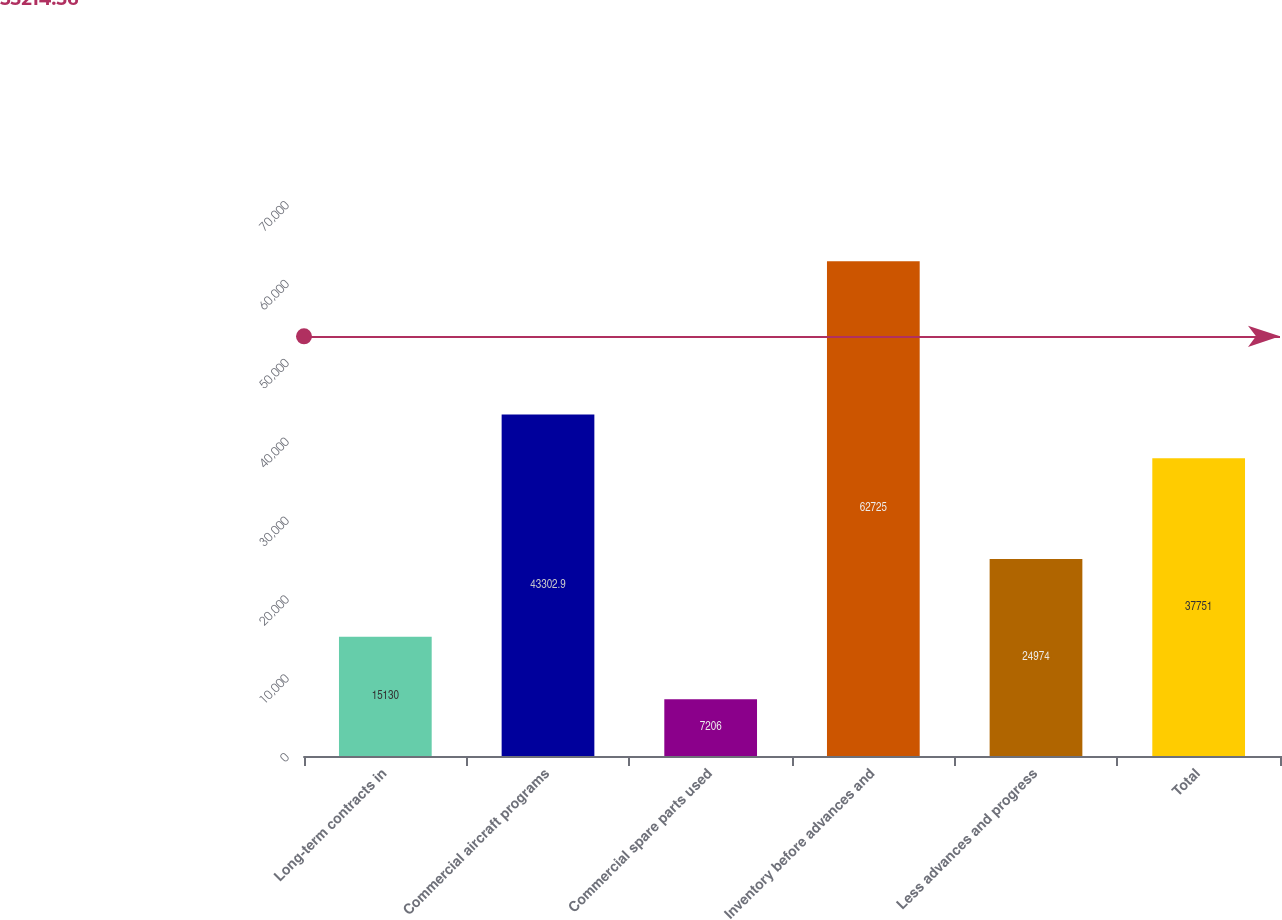<chart> <loc_0><loc_0><loc_500><loc_500><bar_chart><fcel>Long-term contracts in<fcel>Commercial aircraft programs<fcel>Commercial spare parts used<fcel>Inventory before advances and<fcel>Less advances and progress<fcel>Total<nl><fcel>15130<fcel>43302.9<fcel>7206<fcel>62725<fcel>24974<fcel>37751<nl></chart> 